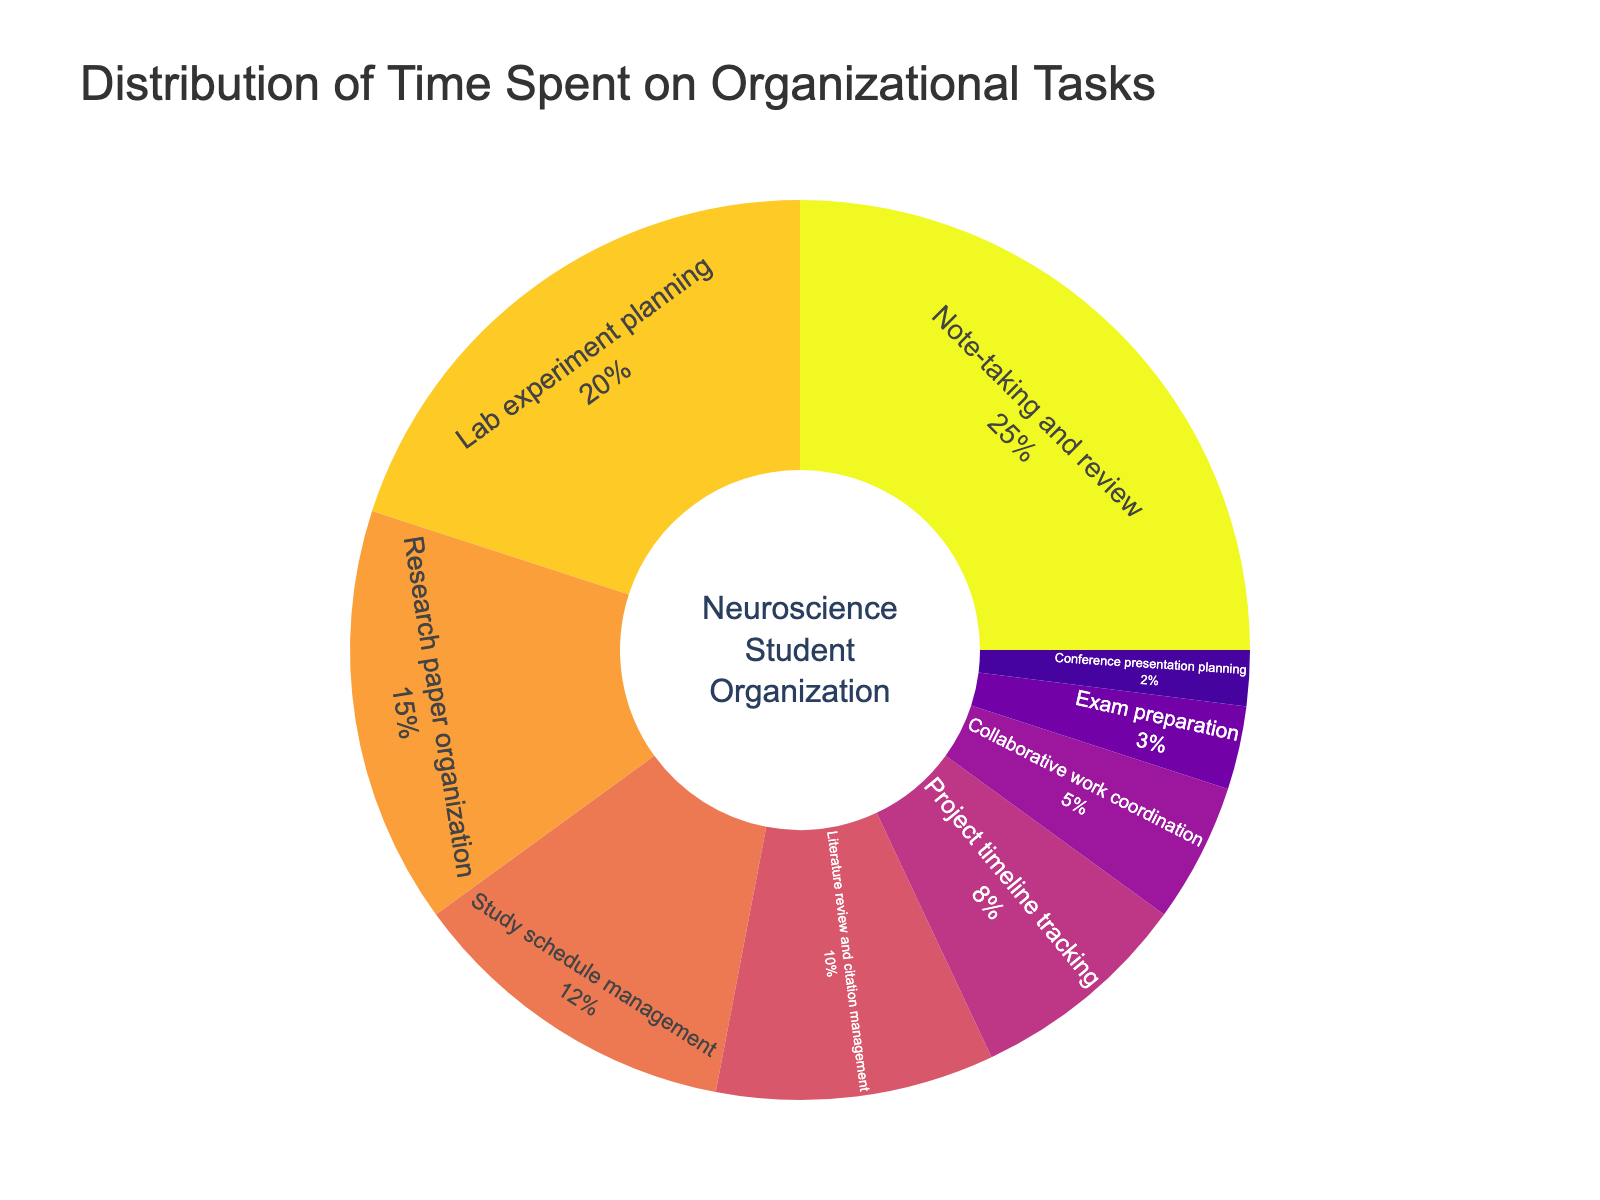What percentage of time is dedicated to literature review and citation management? The figure shows a segment labeled 'Literature review and citation management' with a percentage of time spent.
Answer: 10% What task takes up the most time for successful neuroscience students? The pie chart shows different segments, and 'Note-taking and review' has the largest segment.
Answer: Note-taking and review How much more time is spent on lab experiment planning compared to collaborative work coordination? The time spent on lab experiment planning is 20%, and the time spent on collaborative work coordination is 5%. The difference is 20% - 5%.
Answer: 15% What's the combined percentage of time spent on study schedule management and research paper organization? The percentage for study schedule management is 12%, and for research paper organization, it's 15%. Adding these together gives 12% + 15%.
Answer: 27% Which organizational task is allotted the least amount of time? The smallest segment in the pie chart is labeled 'Conference presentation planning'.
Answer: Conference presentation planning Is the time spent on project timeline tracking greater than the time spent on literature review and citation management? Project timeline tracking takes 8% of the time, while literature review and citation management takes 10%. Since 8% is less than 10%, the answer is no.
Answer: No What is the total percentage of time spent on tasks related to planning (lab experiment planning, project timeline tracking, and conference presentation planning)? Lab experiment planning is 20%, project timeline tracking is 8%, and conference presentation planning is 2%. Adding these together results in 20% + 8% + 2%.
Answer: 30% Compare the time spent on exam preparation and collaborative work coordination. Which one takes more time? Exam preparation takes 3% of the time, whereas collaborative work coordination takes 5%. Since 5% is greater than 3%, collaborative work coordination takes more time.
Answer: Collaborative work coordination How does the percentage of time spent on study schedule management compare to time spent on lab experiment planning? The time spent on study schedule management is 12%, and lab experiment planning is 20%. Since 12% is less than 20%, lab experiment planning takes more time.
Answer: Lab experiment planning If neuroscience students spent an additional 3% of their time on exam preparation, what would the new percentage be? The current time spent on exam preparation is 3%. Adding an additional 3% results in 3% + 3%.
Answer: 6% 